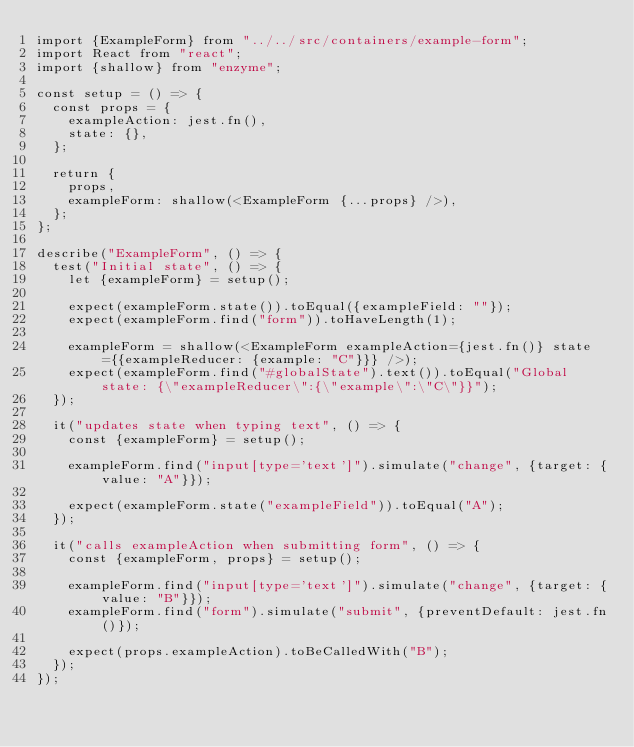<code> <loc_0><loc_0><loc_500><loc_500><_JavaScript_>import {ExampleForm} from "../../src/containers/example-form";
import React from "react";
import {shallow} from "enzyme";

const setup = () => {
  const props = {
    exampleAction: jest.fn(),
    state: {},
  };

  return {
    props,
    exampleForm: shallow(<ExampleForm {...props} />),
  };
};

describe("ExampleForm", () => {
  test("Initial state", () => {
    let {exampleForm} = setup();

    expect(exampleForm.state()).toEqual({exampleField: ""});
    expect(exampleForm.find("form")).toHaveLength(1);

    exampleForm = shallow(<ExampleForm exampleAction={jest.fn()} state={{exampleReducer: {example: "C"}}} />);
    expect(exampleForm.find("#globalState").text()).toEqual("Global state: {\"exampleReducer\":{\"example\":\"C\"}}");
  });

  it("updates state when typing text", () => {
    const {exampleForm} = setup();

    exampleForm.find("input[type='text']").simulate("change", {target: {value: "A"}});

    expect(exampleForm.state("exampleField")).toEqual("A");
  });

  it("calls exampleAction when submitting form", () => {
    const {exampleForm, props} = setup();

    exampleForm.find("input[type='text']").simulate("change", {target: {value: "B"}});
    exampleForm.find("form").simulate("submit", {preventDefault: jest.fn()});

    expect(props.exampleAction).toBeCalledWith("B");
  });
});
</code> 